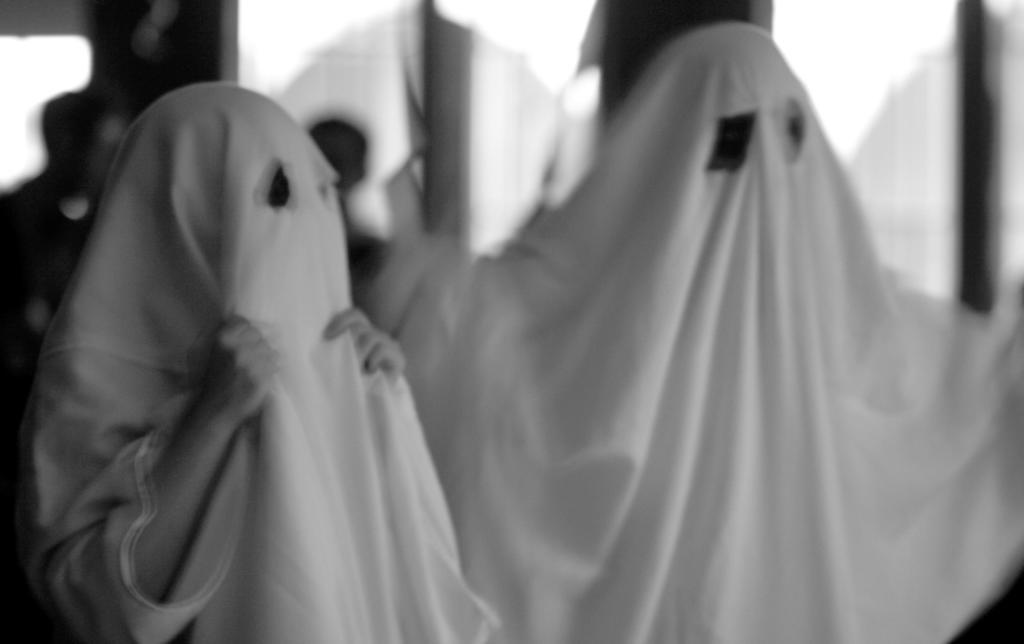How many people are in the foreground of the image? There are two persons in the foreground of the image. What are the persons in the foreground wearing? The persons in the foreground are wearing masks. What can be seen in the background of the image? There is a wall in the background of the image. Are there any other people visible in the image? Yes, there are persons visible on the left side in front of the wall. What type of ray is visible on the right side of the image? There is no ray visible on the right side of the image. Is there a rail present in the image? There is no rail present in the image. 